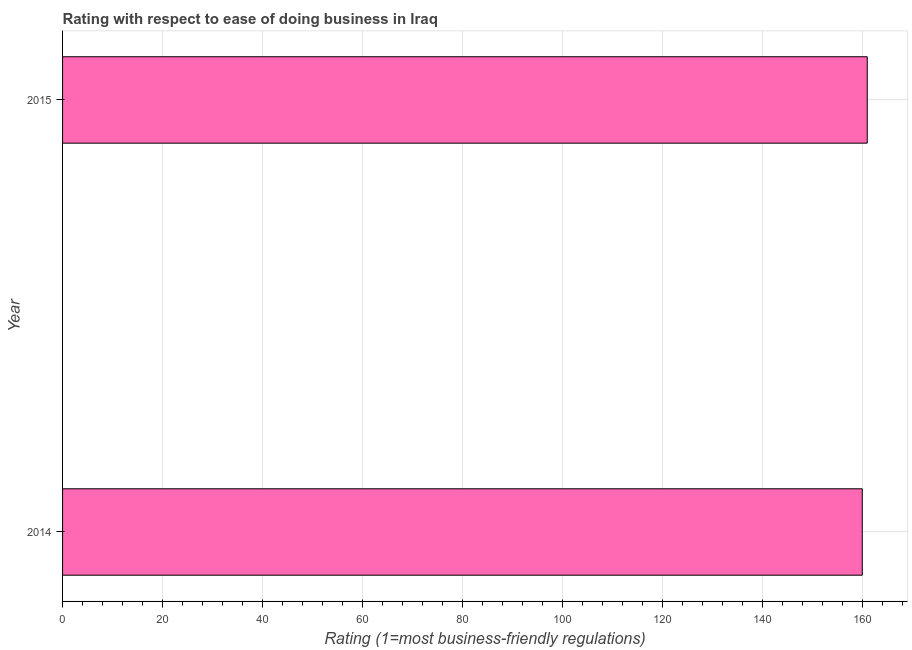Does the graph contain any zero values?
Your response must be concise. No. What is the title of the graph?
Your answer should be compact. Rating with respect to ease of doing business in Iraq. What is the label or title of the X-axis?
Ensure brevity in your answer.  Rating (1=most business-friendly regulations). What is the label or title of the Y-axis?
Ensure brevity in your answer.  Year. What is the ease of doing business index in 2015?
Provide a short and direct response. 161. Across all years, what is the maximum ease of doing business index?
Your answer should be very brief. 161. Across all years, what is the minimum ease of doing business index?
Offer a terse response. 160. In which year was the ease of doing business index maximum?
Your response must be concise. 2015. What is the sum of the ease of doing business index?
Offer a very short reply. 321. What is the average ease of doing business index per year?
Your answer should be compact. 160. What is the median ease of doing business index?
Offer a terse response. 160.5. In how many years, is the ease of doing business index greater than 36 ?
Give a very brief answer. 2. Is the ease of doing business index in 2014 less than that in 2015?
Keep it short and to the point. Yes. How many bars are there?
Your response must be concise. 2. Are all the bars in the graph horizontal?
Offer a terse response. Yes. How many years are there in the graph?
Offer a very short reply. 2. What is the difference between two consecutive major ticks on the X-axis?
Provide a succinct answer. 20. Are the values on the major ticks of X-axis written in scientific E-notation?
Provide a short and direct response. No. What is the Rating (1=most business-friendly regulations) in 2014?
Offer a very short reply. 160. What is the Rating (1=most business-friendly regulations) of 2015?
Ensure brevity in your answer.  161. What is the difference between the Rating (1=most business-friendly regulations) in 2014 and 2015?
Provide a succinct answer. -1. What is the ratio of the Rating (1=most business-friendly regulations) in 2014 to that in 2015?
Offer a very short reply. 0.99. 